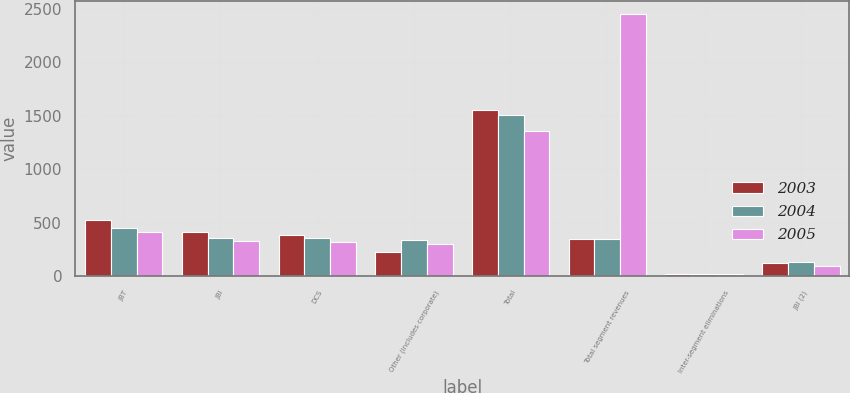<chart> <loc_0><loc_0><loc_500><loc_500><stacked_bar_chart><ecel><fcel>JBT<fcel>JBI<fcel>DCS<fcel>Other (includes corporate)<fcel>Total<fcel>Total segment revenues<fcel>Inter-segment eliminations<fcel>JBI (2)<nl><fcel>2003<fcel>522<fcel>416<fcel>386<fcel>225<fcel>1549<fcel>345<fcel>20<fcel>124<nl><fcel>2004<fcel>454<fcel>359<fcel>355<fcel>335<fcel>1503<fcel>345<fcel>17<fcel>131<nl><fcel>2005<fcel>410<fcel>328<fcel>319<fcel>299<fcel>1356<fcel>2448<fcel>15<fcel>91<nl></chart> 